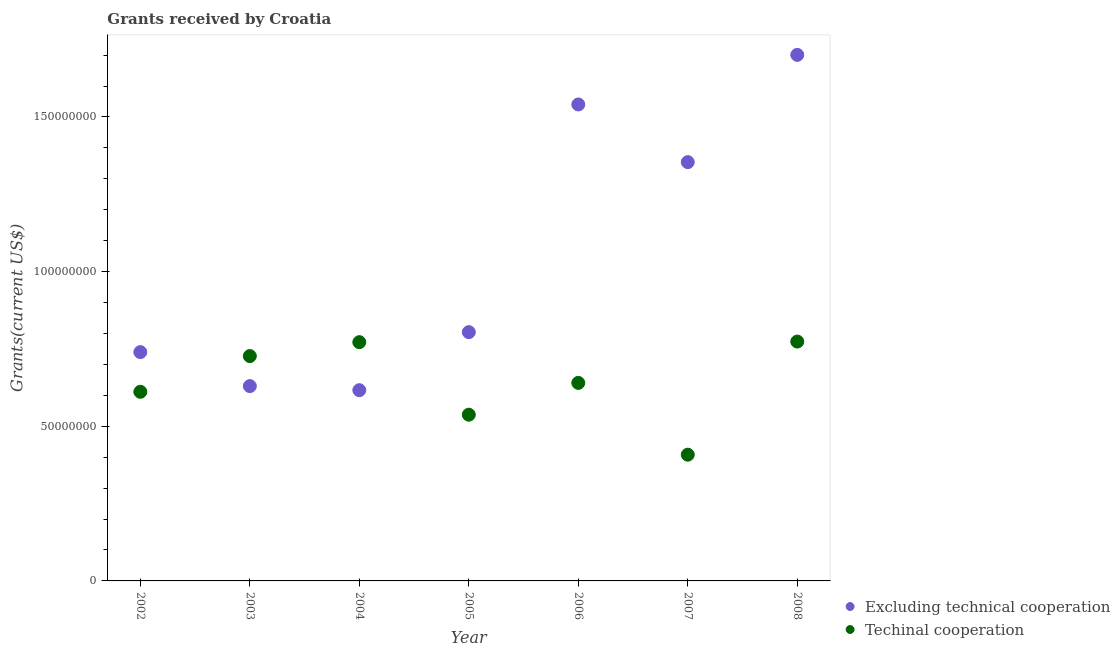How many different coloured dotlines are there?
Your answer should be very brief. 2. What is the amount of grants received(excluding technical cooperation) in 2005?
Offer a very short reply. 8.04e+07. Across all years, what is the maximum amount of grants received(excluding technical cooperation)?
Your answer should be compact. 1.70e+08. Across all years, what is the minimum amount of grants received(excluding technical cooperation)?
Ensure brevity in your answer.  6.17e+07. In which year was the amount of grants received(including technical cooperation) minimum?
Offer a very short reply. 2007. What is the total amount of grants received(excluding technical cooperation) in the graph?
Offer a terse response. 7.39e+08. What is the difference between the amount of grants received(including technical cooperation) in 2003 and that in 2008?
Your answer should be compact. -4.69e+06. What is the difference between the amount of grants received(including technical cooperation) in 2003 and the amount of grants received(excluding technical cooperation) in 2005?
Your response must be concise. -7.74e+06. What is the average amount of grants received(excluding technical cooperation) per year?
Provide a short and direct response. 1.06e+08. In the year 2006, what is the difference between the amount of grants received(excluding technical cooperation) and amount of grants received(including technical cooperation)?
Provide a succinct answer. 9.00e+07. What is the ratio of the amount of grants received(including technical cooperation) in 2003 to that in 2005?
Your answer should be very brief. 1.35. Is the amount of grants received(excluding technical cooperation) in 2003 less than that in 2007?
Give a very brief answer. Yes. What is the difference between the highest and the second highest amount of grants received(including technical cooperation)?
Offer a terse response. 1.90e+05. What is the difference between the highest and the lowest amount of grants received(excluding technical cooperation)?
Offer a very short reply. 1.08e+08. Does the amount of grants received(including technical cooperation) monotonically increase over the years?
Keep it short and to the point. No. Is the amount of grants received(excluding technical cooperation) strictly greater than the amount of grants received(including technical cooperation) over the years?
Your answer should be very brief. No. Is the amount of grants received(including technical cooperation) strictly less than the amount of grants received(excluding technical cooperation) over the years?
Make the answer very short. No. How many dotlines are there?
Ensure brevity in your answer.  2. Does the graph contain any zero values?
Give a very brief answer. No. Where does the legend appear in the graph?
Ensure brevity in your answer.  Bottom right. How are the legend labels stacked?
Keep it short and to the point. Vertical. What is the title of the graph?
Your answer should be very brief. Grants received by Croatia. Does "Commercial service imports" appear as one of the legend labels in the graph?
Keep it short and to the point. No. What is the label or title of the X-axis?
Give a very brief answer. Year. What is the label or title of the Y-axis?
Provide a short and direct response. Grants(current US$). What is the Grants(current US$) of Excluding technical cooperation in 2002?
Offer a terse response. 7.40e+07. What is the Grants(current US$) in Techinal cooperation in 2002?
Give a very brief answer. 6.11e+07. What is the Grants(current US$) of Excluding technical cooperation in 2003?
Give a very brief answer. 6.30e+07. What is the Grants(current US$) of Techinal cooperation in 2003?
Give a very brief answer. 7.27e+07. What is the Grants(current US$) in Excluding technical cooperation in 2004?
Your answer should be very brief. 6.17e+07. What is the Grants(current US$) of Techinal cooperation in 2004?
Provide a short and direct response. 7.72e+07. What is the Grants(current US$) of Excluding technical cooperation in 2005?
Keep it short and to the point. 8.04e+07. What is the Grants(current US$) of Techinal cooperation in 2005?
Offer a very short reply. 5.37e+07. What is the Grants(current US$) in Excluding technical cooperation in 2006?
Offer a terse response. 1.54e+08. What is the Grants(current US$) in Techinal cooperation in 2006?
Keep it short and to the point. 6.40e+07. What is the Grants(current US$) of Excluding technical cooperation in 2007?
Your answer should be very brief. 1.35e+08. What is the Grants(current US$) in Techinal cooperation in 2007?
Offer a very short reply. 4.08e+07. What is the Grants(current US$) of Excluding technical cooperation in 2008?
Keep it short and to the point. 1.70e+08. What is the Grants(current US$) in Techinal cooperation in 2008?
Make the answer very short. 7.74e+07. Across all years, what is the maximum Grants(current US$) of Excluding technical cooperation?
Your answer should be very brief. 1.70e+08. Across all years, what is the maximum Grants(current US$) of Techinal cooperation?
Keep it short and to the point. 7.74e+07. Across all years, what is the minimum Grants(current US$) of Excluding technical cooperation?
Provide a short and direct response. 6.17e+07. Across all years, what is the minimum Grants(current US$) in Techinal cooperation?
Keep it short and to the point. 4.08e+07. What is the total Grants(current US$) of Excluding technical cooperation in the graph?
Your answer should be very brief. 7.39e+08. What is the total Grants(current US$) in Techinal cooperation in the graph?
Your response must be concise. 4.47e+08. What is the difference between the Grants(current US$) in Excluding technical cooperation in 2002 and that in 2003?
Offer a terse response. 1.10e+07. What is the difference between the Grants(current US$) in Techinal cooperation in 2002 and that in 2003?
Your answer should be compact. -1.16e+07. What is the difference between the Grants(current US$) in Excluding technical cooperation in 2002 and that in 2004?
Ensure brevity in your answer.  1.23e+07. What is the difference between the Grants(current US$) of Techinal cooperation in 2002 and that in 2004?
Offer a very short reply. -1.60e+07. What is the difference between the Grants(current US$) of Excluding technical cooperation in 2002 and that in 2005?
Give a very brief answer. -6.46e+06. What is the difference between the Grants(current US$) of Techinal cooperation in 2002 and that in 2005?
Your answer should be very brief. 7.40e+06. What is the difference between the Grants(current US$) in Excluding technical cooperation in 2002 and that in 2006?
Your answer should be very brief. -8.01e+07. What is the difference between the Grants(current US$) of Techinal cooperation in 2002 and that in 2006?
Ensure brevity in your answer.  -2.88e+06. What is the difference between the Grants(current US$) of Excluding technical cooperation in 2002 and that in 2007?
Make the answer very short. -6.14e+07. What is the difference between the Grants(current US$) of Techinal cooperation in 2002 and that in 2007?
Your response must be concise. 2.03e+07. What is the difference between the Grants(current US$) in Excluding technical cooperation in 2002 and that in 2008?
Provide a short and direct response. -9.61e+07. What is the difference between the Grants(current US$) in Techinal cooperation in 2002 and that in 2008?
Keep it short and to the point. -1.62e+07. What is the difference between the Grants(current US$) of Excluding technical cooperation in 2003 and that in 2004?
Your answer should be compact. 1.32e+06. What is the difference between the Grants(current US$) in Techinal cooperation in 2003 and that in 2004?
Your answer should be very brief. -4.50e+06. What is the difference between the Grants(current US$) of Excluding technical cooperation in 2003 and that in 2005?
Make the answer very short. -1.74e+07. What is the difference between the Grants(current US$) of Techinal cooperation in 2003 and that in 2005?
Offer a terse response. 1.90e+07. What is the difference between the Grants(current US$) in Excluding technical cooperation in 2003 and that in 2006?
Provide a short and direct response. -9.11e+07. What is the difference between the Grants(current US$) of Techinal cooperation in 2003 and that in 2006?
Make the answer very short. 8.67e+06. What is the difference between the Grants(current US$) of Excluding technical cooperation in 2003 and that in 2007?
Offer a terse response. -7.24e+07. What is the difference between the Grants(current US$) in Techinal cooperation in 2003 and that in 2007?
Offer a very short reply. 3.19e+07. What is the difference between the Grants(current US$) of Excluding technical cooperation in 2003 and that in 2008?
Offer a terse response. -1.07e+08. What is the difference between the Grants(current US$) in Techinal cooperation in 2003 and that in 2008?
Keep it short and to the point. -4.69e+06. What is the difference between the Grants(current US$) of Excluding technical cooperation in 2004 and that in 2005?
Offer a very short reply. -1.88e+07. What is the difference between the Grants(current US$) of Techinal cooperation in 2004 and that in 2005?
Provide a short and direct response. 2.34e+07. What is the difference between the Grants(current US$) of Excluding technical cooperation in 2004 and that in 2006?
Provide a succinct answer. -9.24e+07. What is the difference between the Grants(current US$) of Techinal cooperation in 2004 and that in 2006?
Provide a succinct answer. 1.32e+07. What is the difference between the Grants(current US$) in Excluding technical cooperation in 2004 and that in 2007?
Your response must be concise. -7.37e+07. What is the difference between the Grants(current US$) in Techinal cooperation in 2004 and that in 2007?
Keep it short and to the point. 3.64e+07. What is the difference between the Grants(current US$) of Excluding technical cooperation in 2004 and that in 2008?
Your response must be concise. -1.08e+08. What is the difference between the Grants(current US$) of Excluding technical cooperation in 2005 and that in 2006?
Your answer should be compact. -7.36e+07. What is the difference between the Grants(current US$) of Techinal cooperation in 2005 and that in 2006?
Your response must be concise. -1.03e+07. What is the difference between the Grants(current US$) in Excluding technical cooperation in 2005 and that in 2007?
Offer a very short reply. -5.50e+07. What is the difference between the Grants(current US$) in Techinal cooperation in 2005 and that in 2007?
Provide a succinct answer. 1.29e+07. What is the difference between the Grants(current US$) of Excluding technical cooperation in 2005 and that in 2008?
Offer a very short reply. -8.96e+07. What is the difference between the Grants(current US$) of Techinal cooperation in 2005 and that in 2008?
Ensure brevity in your answer.  -2.36e+07. What is the difference between the Grants(current US$) in Excluding technical cooperation in 2006 and that in 2007?
Your response must be concise. 1.86e+07. What is the difference between the Grants(current US$) in Techinal cooperation in 2006 and that in 2007?
Keep it short and to the point. 2.32e+07. What is the difference between the Grants(current US$) of Excluding technical cooperation in 2006 and that in 2008?
Make the answer very short. -1.60e+07. What is the difference between the Grants(current US$) of Techinal cooperation in 2006 and that in 2008?
Ensure brevity in your answer.  -1.34e+07. What is the difference between the Grants(current US$) of Excluding technical cooperation in 2007 and that in 2008?
Your answer should be compact. -3.47e+07. What is the difference between the Grants(current US$) of Techinal cooperation in 2007 and that in 2008?
Your answer should be very brief. -3.66e+07. What is the difference between the Grants(current US$) of Excluding technical cooperation in 2002 and the Grants(current US$) of Techinal cooperation in 2003?
Your response must be concise. 1.28e+06. What is the difference between the Grants(current US$) in Excluding technical cooperation in 2002 and the Grants(current US$) in Techinal cooperation in 2004?
Offer a terse response. -3.22e+06. What is the difference between the Grants(current US$) in Excluding technical cooperation in 2002 and the Grants(current US$) in Techinal cooperation in 2005?
Offer a very short reply. 2.02e+07. What is the difference between the Grants(current US$) in Excluding technical cooperation in 2002 and the Grants(current US$) in Techinal cooperation in 2006?
Offer a very short reply. 9.95e+06. What is the difference between the Grants(current US$) of Excluding technical cooperation in 2002 and the Grants(current US$) of Techinal cooperation in 2007?
Your response must be concise. 3.32e+07. What is the difference between the Grants(current US$) of Excluding technical cooperation in 2002 and the Grants(current US$) of Techinal cooperation in 2008?
Keep it short and to the point. -3.41e+06. What is the difference between the Grants(current US$) in Excluding technical cooperation in 2003 and the Grants(current US$) in Techinal cooperation in 2004?
Make the answer very short. -1.42e+07. What is the difference between the Grants(current US$) of Excluding technical cooperation in 2003 and the Grants(current US$) of Techinal cooperation in 2005?
Keep it short and to the point. 9.24e+06. What is the difference between the Grants(current US$) in Excluding technical cooperation in 2003 and the Grants(current US$) in Techinal cooperation in 2006?
Provide a short and direct response. -1.04e+06. What is the difference between the Grants(current US$) of Excluding technical cooperation in 2003 and the Grants(current US$) of Techinal cooperation in 2007?
Your response must be concise. 2.22e+07. What is the difference between the Grants(current US$) of Excluding technical cooperation in 2003 and the Grants(current US$) of Techinal cooperation in 2008?
Your response must be concise. -1.44e+07. What is the difference between the Grants(current US$) in Excluding technical cooperation in 2004 and the Grants(current US$) in Techinal cooperation in 2005?
Your answer should be very brief. 7.92e+06. What is the difference between the Grants(current US$) of Excluding technical cooperation in 2004 and the Grants(current US$) of Techinal cooperation in 2006?
Ensure brevity in your answer.  -2.36e+06. What is the difference between the Grants(current US$) in Excluding technical cooperation in 2004 and the Grants(current US$) in Techinal cooperation in 2007?
Offer a very short reply. 2.08e+07. What is the difference between the Grants(current US$) in Excluding technical cooperation in 2004 and the Grants(current US$) in Techinal cooperation in 2008?
Provide a succinct answer. -1.57e+07. What is the difference between the Grants(current US$) in Excluding technical cooperation in 2005 and the Grants(current US$) in Techinal cooperation in 2006?
Your response must be concise. 1.64e+07. What is the difference between the Grants(current US$) of Excluding technical cooperation in 2005 and the Grants(current US$) of Techinal cooperation in 2007?
Offer a terse response. 3.96e+07. What is the difference between the Grants(current US$) of Excluding technical cooperation in 2005 and the Grants(current US$) of Techinal cooperation in 2008?
Provide a succinct answer. 3.05e+06. What is the difference between the Grants(current US$) of Excluding technical cooperation in 2006 and the Grants(current US$) of Techinal cooperation in 2007?
Offer a terse response. 1.13e+08. What is the difference between the Grants(current US$) in Excluding technical cooperation in 2006 and the Grants(current US$) in Techinal cooperation in 2008?
Your answer should be compact. 7.67e+07. What is the difference between the Grants(current US$) of Excluding technical cooperation in 2007 and the Grants(current US$) of Techinal cooperation in 2008?
Your response must be concise. 5.80e+07. What is the average Grants(current US$) of Excluding technical cooperation per year?
Offer a very short reply. 1.06e+08. What is the average Grants(current US$) in Techinal cooperation per year?
Your answer should be compact. 6.39e+07. In the year 2002, what is the difference between the Grants(current US$) in Excluding technical cooperation and Grants(current US$) in Techinal cooperation?
Provide a succinct answer. 1.28e+07. In the year 2003, what is the difference between the Grants(current US$) in Excluding technical cooperation and Grants(current US$) in Techinal cooperation?
Provide a short and direct response. -9.71e+06. In the year 2004, what is the difference between the Grants(current US$) in Excluding technical cooperation and Grants(current US$) in Techinal cooperation?
Your answer should be very brief. -1.55e+07. In the year 2005, what is the difference between the Grants(current US$) of Excluding technical cooperation and Grants(current US$) of Techinal cooperation?
Keep it short and to the point. 2.67e+07. In the year 2006, what is the difference between the Grants(current US$) in Excluding technical cooperation and Grants(current US$) in Techinal cooperation?
Provide a succinct answer. 9.00e+07. In the year 2007, what is the difference between the Grants(current US$) in Excluding technical cooperation and Grants(current US$) in Techinal cooperation?
Give a very brief answer. 9.46e+07. In the year 2008, what is the difference between the Grants(current US$) of Excluding technical cooperation and Grants(current US$) of Techinal cooperation?
Give a very brief answer. 9.27e+07. What is the ratio of the Grants(current US$) in Excluding technical cooperation in 2002 to that in 2003?
Provide a succinct answer. 1.17. What is the ratio of the Grants(current US$) of Techinal cooperation in 2002 to that in 2003?
Give a very brief answer. 0.84. What is the ratio of the Grants(current US$) of Excluding technical cooperation in 2002 to that in 2004?
Ensure brevity in your answer.  1.2. What is the ratio of the Grants(current US$) of Techinal cooperation in 2002 to that in 2004?
Provide a succinct answer. 0.79. What is the ratio of the Grants(current US$) of Excluding technical cooperation in 2002 to that in 2005?
Offer a terse response. 0.92. What is the ratio of the Grants(current US$) in Techinal cooperation in 2002 to that in 2005?
Make the answer very short. 1.14. What is the ratio of the Grants(current US$) in Excluding technical cooperation in 2002 to that in 2006?
Your answer should be compact. 0.48. What is the ratio of the Grants(current US$) of Techinal cooperation in 2002 to that in 2006?
Give a very brief answer. 0.95. What is the ratio of the Grants(current US$) of Excluding technical cooperation in 2002 to that in 2007?
Provide a succinct answer. 0.55. What is the ratio of the Grants(current US$) of Techinal cooperation in 2002 to that in 2007?
Ensure brevity in your answer.  1.5. What is the ratio of the Grants(current US$) of Excluding technical cooperation in 2002 to that in 2008?
Make the answer very short. 0.43. What is the ratio of the Grants(current US$) in Techinal cooperation in 2002 to that in 2008?
Ensure brevity in your answer.  0.79. What is the ratio of the Grants(current US$) of Excluding technical cooperation in 2003 to that in 2004?
Give a very brief answer. 1.02. What is the ratio of the Grants(current US$) of Techinal cooperation in 2003 to that in 2004?
Provide a short and direct response. 0.94. What is the ratio of the Grants(current US$) in Excluding technical cooperation in 2003 to that in 2005?
Keep it short and to the point. 0.78. What is the ratio of the Grants(current US$) in Techinal cooperation in 2003 to that in 2005?
Keep it short and to the point. 1.35. What is the ratio of the Grants(current US$) of Excluding technical cooperation in 2003 to that in 2006?
Offer a very short reply. 0.41. What is the ratio of the Grants(current US$) in Techinal cooperation in 2003 to that in 2006?
Offer a terse response. 1.14. What is the ratio of the Grants(current US$) in Excluding technical cooperation in 2003 to that in 2007?
Your response must be concise. 0.47. What is the ratio of the Grants(current US$) in Techinal cooperation in 2003 to that in 2007?
Offer a terse response. 1.78. What is the ratio of the Grants(current US$) in Excluding technical cooperation in 2003 to that in 2008?
Your answer should be compact. 0.37. What is the ratio of the Grants(current US$) in Techinal cooperation in 2003 to that in 2008?
Give a very brief answer. 0.94. What is the ratio of the Grants(current US$) of Excluding technical cooperation in 2004 to that in 2005?
Provide a short and direct response. 0.77. What is the ratio of the Grants(current US$) in Techinal cooperation in 2004 to that in 2005?
Offer a very short reply. 1.44. What is the ratio of the Grants(current US$) in Excluding technical cooperation in 2004 to that in 2006?
Your answer should be very brief. 0.4. What is the ratio of the Grants(current US$) in Techinal cooperation in 2004 to that in 2006?
Offer a very short reply. 1.21. What is the ratio of the Grants(current US$) of Excluding technical cooperation in 2004 to that in 2007?
Give a very brief answer. 0.46. What is the ratio of the Grants(current US$) of Techinal cooperation in 2004 to that in 2007?
Give a very brief answer. 1.89. What is the ratio of the Grants(current US$) in Excluding technical cooperation in 2004 to that in 2008?
Your response must be concise. 0.36. What is the ratio of the Grants(current US$) of Excluding technical cooperation in 2005 to that in 2006?
Offer a very short reply. 0.52. What is the ratio of the Grants(current US$) in Techinal cooperation in 2005 to that in 2006?
Offer a terse response. 0.84. What is the ratio of the Grants(current US$) of Excluding technical cooperation in 2005 to that in 2007?
Provide a succinct answer. 0.59. What is the ratio of the Grants(current US$) in Techinal cooperation in 2005 to that in 2007?
Your response must be concise. 1.32. What is the ratio of the Grants(current US$) of Excluding technical cooperation in 2005 to that in 2008?
Make the answer very short. 0.47. What is the ratio of the Grants(current US$) of Techinal cooperation in 2005 to that in 2008?
Make the answer very short. 0.69. What is the ratio of the Grants(current US$) of Excluding technical cooperation in 2006 to that in 2007?
Your response must be concise. 1.14. What is the ratio of the Grants(current US$) of Techinal cooperation in 2006 to that in 2007?
Provide a short and direct response. 1.57. What is the ratio of the Grants(current US$) of Excluding technical cooperation in 2006 to that in 2008?
Give a very brief answer. 0.91. What is the ratio of the Grants(current US$) in Techinal cooperation in 2006 to that in 2008?
Provide a short and direct response. 0.83. What is the ratio of the Grants(current US$) of Excluding technical cooperation in 2007 to that in 2008?
Offer a very short reply. 0.8. What is the ratio of the Grants(current US$) in Techinal cooperation in 2007 to that in 2008?
Ensure brevity in your answer.  0.53. What is the difference between the highest and the second highest Grants(current US$) in Excluding technical cooperation?
Keep it short and to the point. 1.60e+07. What is the difference between the highest and the lowest Grants(current US$) in Excluding technical cooperation?
Your answer should be compact. 1.08e+08. What is the difference between the highest and the lowest Grants(current US$) of Techinal cooperation?
Provide a succinct answer. 3.66e+07. 